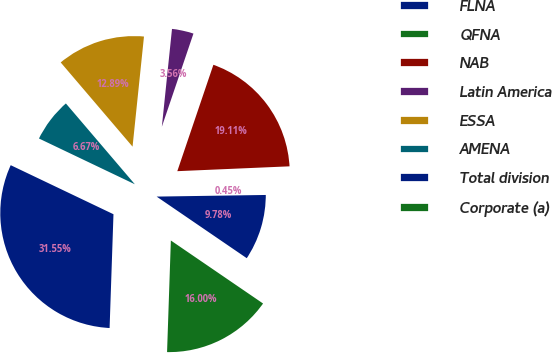Convert chart. <chart><loc_0><loc_0><loc_500><loc_500><pie_chart><fcel>FLNA<fcel>QFNA<fcel>NAB<fcel>Latin America<fcel>ESSA<fcel>AMENA<fcel>Total division<fcel>Corporate (a)<nl><fcel>9.78%<fcel>0.45%<fcel>19.11%<fcel>3.56%<fcel>12.89%<fcel>6.67%<fcel>31.55%<fcel>16.0%<nl></chart> 